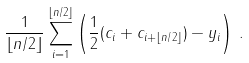<formula> <loc_0><loc_0><loc_500><loc_500>\frac { 1 } { \lfloor n / 2 \rfloor } \sum _ { i = 1 } ^ { \lfloor n / 2 \rfloor } \left ( \frac { 1 } { 2 } ( c _ { i } + c _ { i + \lfloor n / 2 \rfloor } ) - y _ { i } \right ) \, .</formula> 